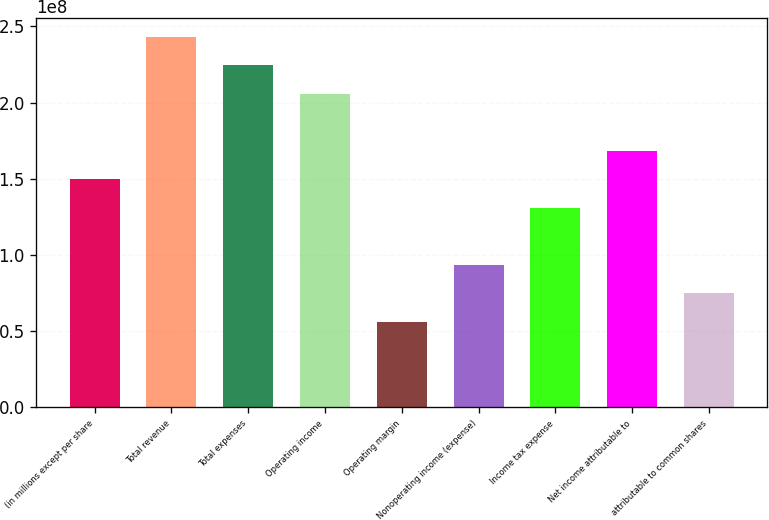<chart> <loc_0><loc_0><loc_500><loc_500><bar_chart><fcel>(in millions except per share<fcel>Total revenue<fcel>Total expenses<fcel>Operating income<fcel>Operating margin<fcel>Nonoperating income (expense)<fcel>Income tax expense<fcel>Net income attributable to<fcel>attributable to common shares<nl><fcel>1.49693e+08<fcel>2.43251e+08<fcel>2.2454e+08<fcel>2.05828e+08<fcel>5.61349e+07<fcel>9.35582e+07<fcel>1.30981e+08<fcel>1.68405e+08<fcel>7.48466e+07<nl></chart> 